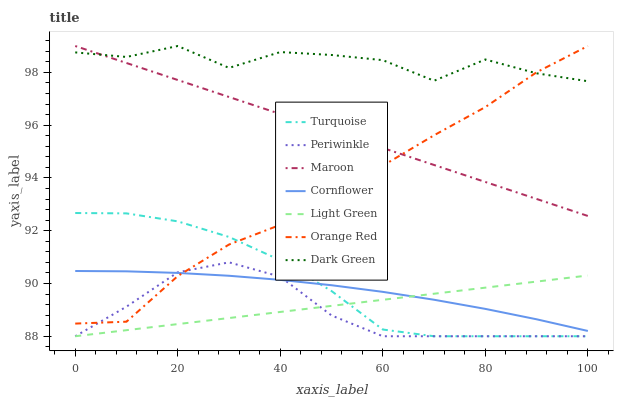Does Periwinkle have the minimum area under the curve?
Answer yes or no. Yes. Does Dark Green have the maximum area under the curve?
Answer yes or no. Yes. Does Turquoise have the minimum area under the curve?
Answer yes or no. No. Does Turquoise have the maximum area under the curve?
Answer yes or no. No. Is Maroon the smoothest?
Answer yes or no. Yes. Is Dark Green the roughest?
Answer yes or no. Yes. Is Turquoise the smoothest?
Answer yes or no. No. Is Turquoise the roughest?
Answer yes or no. No. Does Turquoise have the lowest value?
Answer yes or no. Yes. Does Maroon have the lowest value?
Answer yes or no. No. Does Dark Green have the highest value?
Answer yes or no. Yes. Does Turquoise have the highest value?
Answer yes or no. No. Is Cornflower less than Dark Green?
Answer yes or no. Yes. Is Dark Green greater than Cornflower?
Answer yes or no. Yes. Does Orange Red intersect Cornflower?
Answer yes or no. Yes. Is Orange Red less than Cornflower?
Answer yes or no. No. Is Orange Red greater than Cornflower?
Answer yes or no. No. Does Cornflower intersect Dark Green?
Answer yes or no. No. 